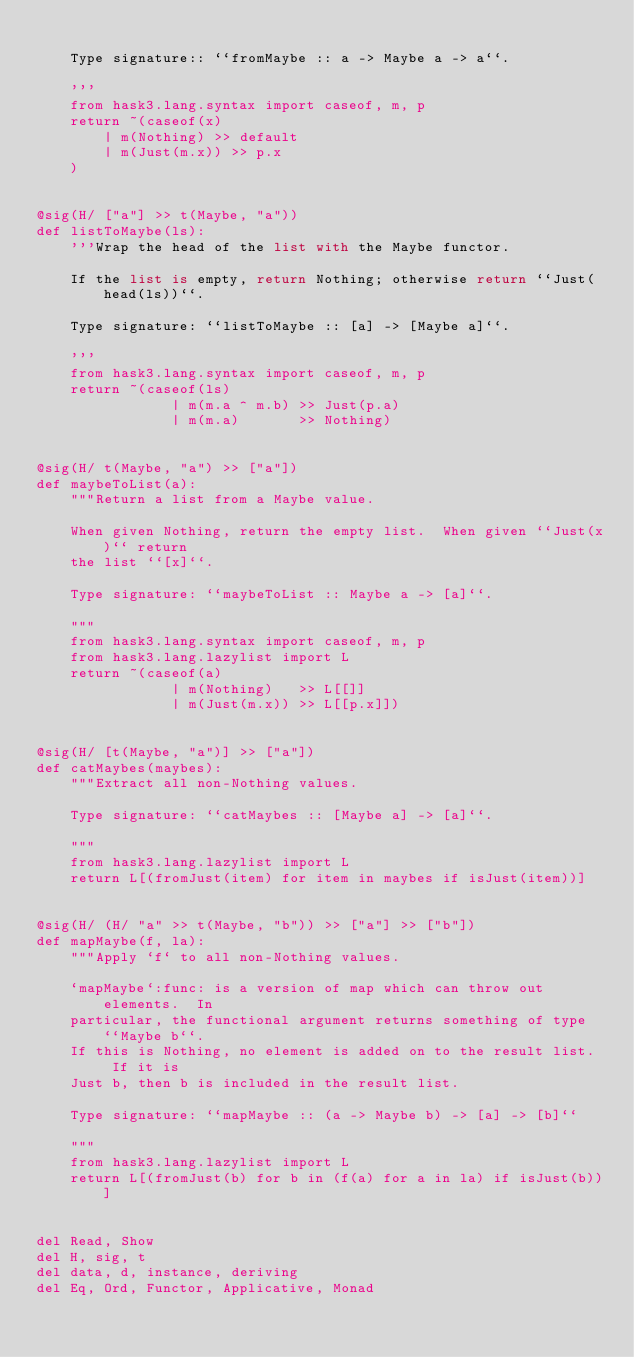<code> <loc_0><loc_0><loc_500><loc_500><_Python_>
    Type signature:: ``fromMaybe :: a -> Maybe a -> a``.

    '''
    from hask3.lang.syntax import caseof, m, p
    return ~(caseof(x)
        | m(Nothing) >> default
        | m(Just(m.x)) >> p.x
    )


@sig(H/ ["a"] >> t(Maybe, "a"))
def listToMaybe(ls):
    '''Wrap the head of the list with the Maybe functor.

    If the list is empty, return Nothing; otherwise return ``Just(head(ls))``.

    Type signature: ``listToMaybe :: [a] -> [Maybe a]``.

    '''
    from hask3.lang.syntax import caseof, m, p
    return ~(caseof(ls)
                | m(m.a ^ m.b) >> Just(p.a)
                | m(m.a)       >> Nothing)


@sig(H/ t(Maybe, "a") >> ["a"])
def maybeToList(a):
    """Return a list from a Maybe value.

    When given Nothing, return the empty list.  When given ``Just(x)`` return
    the list ``[x]``.

    Type signature: ``maybeToList :: Maybe a -> [a]``.

    """
    from hask3.lang.syntax import caseof, m, p
    from hask3.lang.lazylist import L
    return ~(caseof(a)
                | m(Nothing)   >> L[[]]
                | m(Just(m.x)) >> L[[p.x]])


@sig(H/ [t(Maybe, "a")] >> ["a"])
def catMaybes(maybes):
    """Extract all non-Nothing values.

    Type signature: ``catMaybes :: [Maybe a] -> [a]``.

    """
    from hask3.lang.lazylist import L
    return L[(fromJust(item) for item in maybes if isJust(item))]


@sig(H/ (H/ "a" >> t(Maybe, "b")) >> ["a"] >> ["b"])
def mapMaybe(f, la):
    """Apply `f` to all non-Nothing values.

    `mapMaybe`:func: is a version of map which can throw out elements.  In
    particular, the functional argument returns something of type ``Maybe b``.
    If this is Nothing, no element is added on to the result list.  If it is
    Just b, then b is included in the result list.

    Type signature: ``mapMaybe :: (a -> Maybe b) -> [a] -> [b]``

    """
    from hask3.lang.lazylist import L
    return L[(fromJust(b) for b in (f(a) for a in la) if isJust(b))]


del Read, Show
del H, sig, t
del data, d, instance, deriving
del Eq, Ord, Functor, Applicative, Monad
</code> 